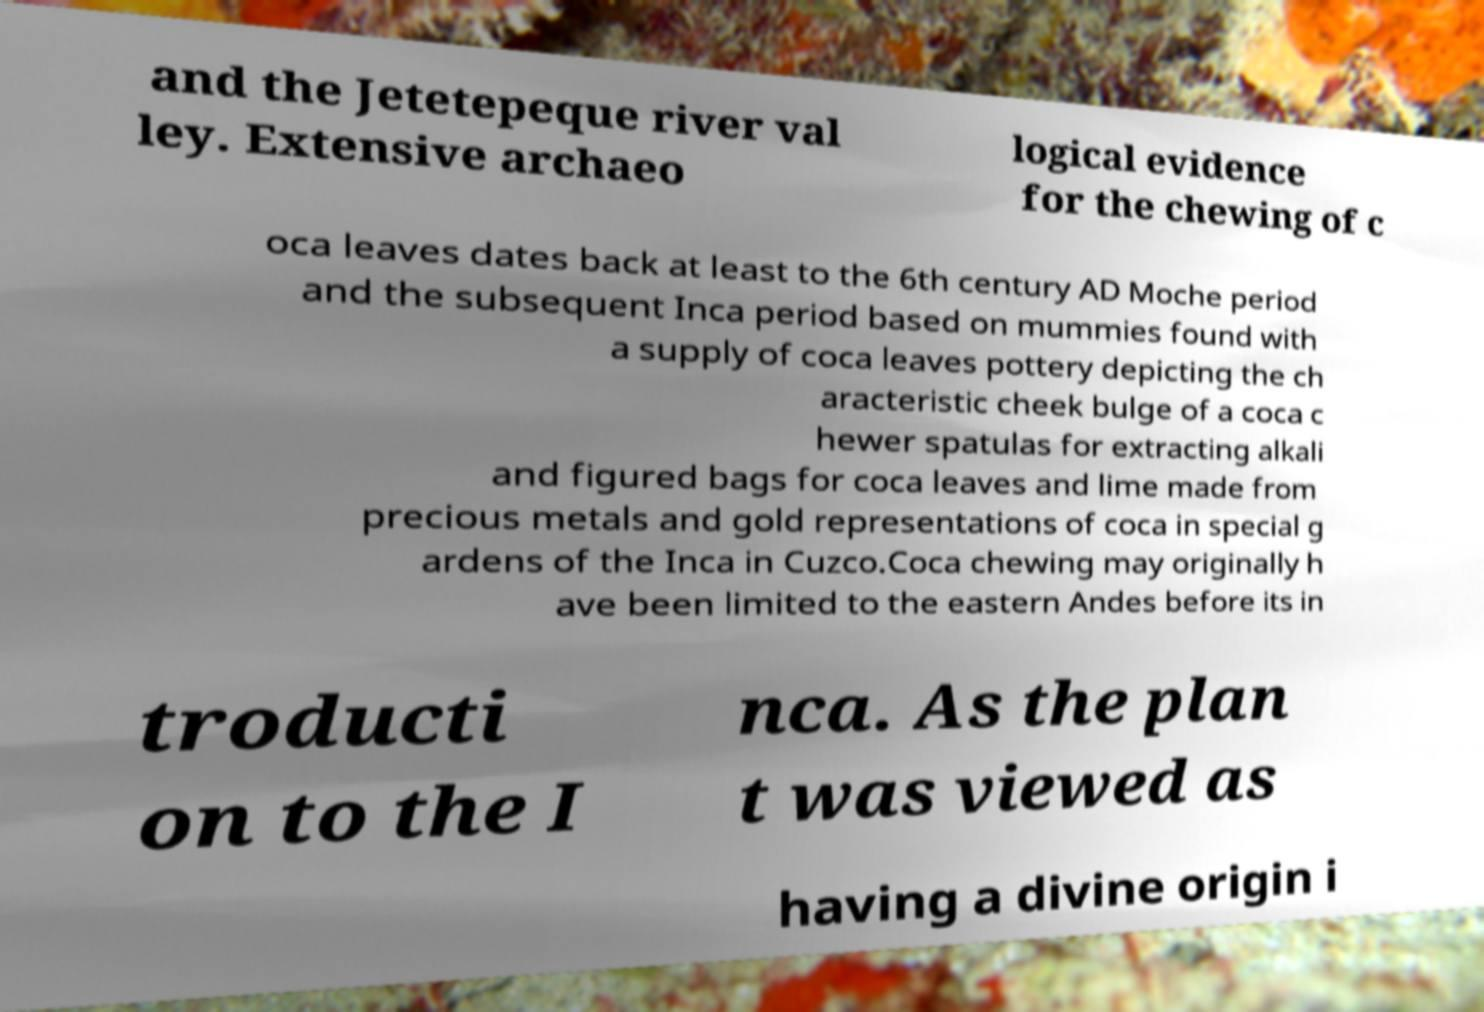I need the written content from this picture converted into text. Can you do that? and the Jetetepeque river val ley. Extensive archaeo logical evidence for the chewing of c oca leaves dates back at least to the 6th century AD Moche period and the subsequent Inca period based on mummies found with a supply of coca leaves pottery depicting the ch aracteristic cheek bulge of a coca c hewer spatulas for extracting alkali and figured bags for coca leaves and lime made from precious metals and gold representations of coca in special g ardens of the Inca in Cuzco.Coca chewing may originally h ave been limited to the eastern Andes before its in troducti on to the I nca. As the plan t was viewed as having a divine origin i 